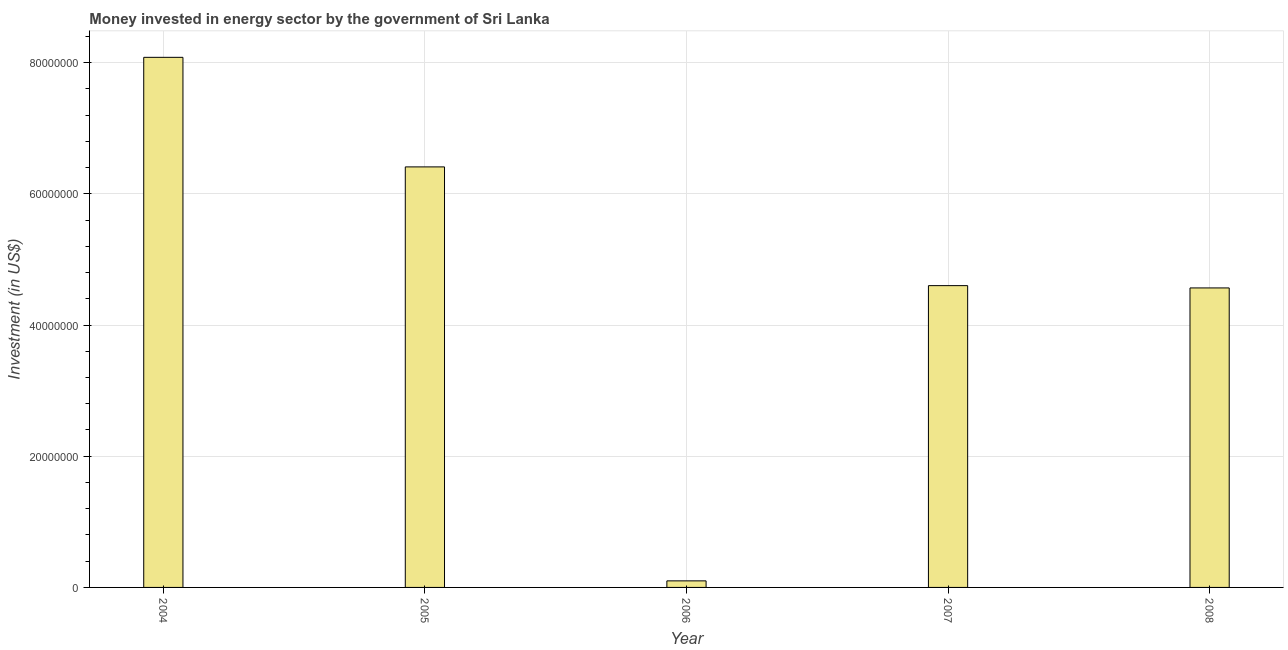Does the graph contain any zero values?
Provide a short and direct response. No. Does the graph contain grids?
Offer a terse response. Yes. What is the title of the graph?
Provide a succinct answer. Money invested in energy sector by the government of Sri Lanka. What is the label or title of the Y-axis?
Provide a succinct answer. Investment (in US$). What is the investment in energy in 2004?
Make the answer very short. 8.08e+07. Across all years, what is the maximum investment in energy?
Your answer should be compact. 8.08e+07. Across all years, what is the minimum investment in energy?
Your answer should be compact. 1.00e+06. In which year was the investment in energy maximum?
Offer a very short reply. 2004. What is the sum of the investment in energy?
Provide a succinct answer. 2.38e+08. What is the difference between the investment in energy in 2004 and 2007?
Your response must be concise. 3.48e+07. What is the average investment in energy per year?
Provide a succinct answer. 4.75e+07. What is the median investment in energy?
Your answer should be compact. 4.60e+07. Do a majority of the years between 2006 and 2007 (inclusive) have investment in energy greater than 36000000 US$?
Your response must be concise. No. What is the ratio of the investment in energy in 2005 to that in 2006?
Offer a terse response. 64.1. What is the difference between the highest and the second highest investment in energy?
Make the answer very short. 1.67e+07. What is the difference between the highest and the lowest investment in energy?
Make the answer very short. 7.98e+07. In how many years, is the investment in energy greater than the average investment in energy taken over all years?
Your response must be concise. 2. What is the Investment (in US$) in 2004?
Your response must be concise. 8.08e+07. What is the Investment (in US$) in 2005?
Keep it short and to the point. 6.41e+07. What is the Investment (in US$) of 2006?
Provide a succinct answer. 1.00e+06. What is the Investment (in US$) of 2007?
Your response must be concise. 4.60e+07. What is the Investment (in US$) of 2008?
Give a very brief answer. 4.56e+07. What is the difference between the Investment (in US$) in 2004 and 2005?
Provide a short and direct response. 1.67e+07. What is the difference between the Investment (in US$) in 2004 and 2006?
Ensure brevity in your answer.  7.98e+07. What is the difference between the Investment (in US$) in 2004 and 2007?
Your response must be concise. 3.48e+07. What is the difference between the Investment (in US$) in 2004 and 2008?
Your response must be concise. 3.52e+07. What is the difference between the Investment (in US$) in 2005 and 2006?
Your answer should be very brief. 6.31e+07. What is the difference between the Investment (in US$) in 2005 and 2007?
Make the answer very short. 1.81e+07. What is the difference between the Investment (in US$) in 2005 and 2008?
Give a very brief answer. 1.84e+07. What is the difference between the Investment (in US$) in 2006 and 2007?
Offer a terse response. -4.50e+07. What is the difference between the Investment (in US$) in 2006 and 2008?
Give a very brief answer. -4.46e+07. What is the ratio of the Investment (in US$) in 2004 to that in 2005?
Provide a succinct answer. 1.26. What is the ratio of the Investment (in US$) in 2004 to that in 2006?
Your answer should be very brief. 80.8. What is the ratio of the Investment (in US$) in 2004 to that in 2007?
Provide a succinct answer. 1.76. What is the ratio of the Investment (in US$) in 2004 to that in 2008?
Offer a terse response. 1.77. What is the ratio of the Investment (in US$) in 2005 to that in 2006?
Ensure brevity in your answer.  64.1. What is the ratio of the Investment (in US$) in 2005 to that in 2007?
Ensure brevity in your answer.  1.39. What is the ratio of the Investment (in US$) in 2005 to that in 2008?
Offer a very short reply. 1.4. What is the ratio of the Investment (in US$) in 2006 to that in 2007?
Offer a very short reply. 0.02. What is the ratio of the Investment (in US$) in 2006 to that in 2008?
Offer a terse response. 0.02. What is the ratio of the Investment (in US$) in 2007 to that in 2008?
Your response must be concise. 1.01. 